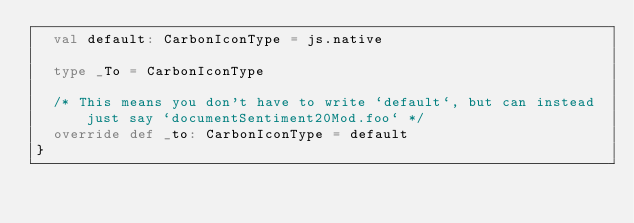Convert code to text. <code><loc_0><loc_0><loc_500><loc_500><_Scala_>  val default: CarbonIconType = js.native
  
  type _To = CarbonIconType
  
  /* This means you don't have to write `default`, but can instead just say `documentSentiment20Mod.foo` */
  override def _to: CarbonIconType = default
}
</code> 